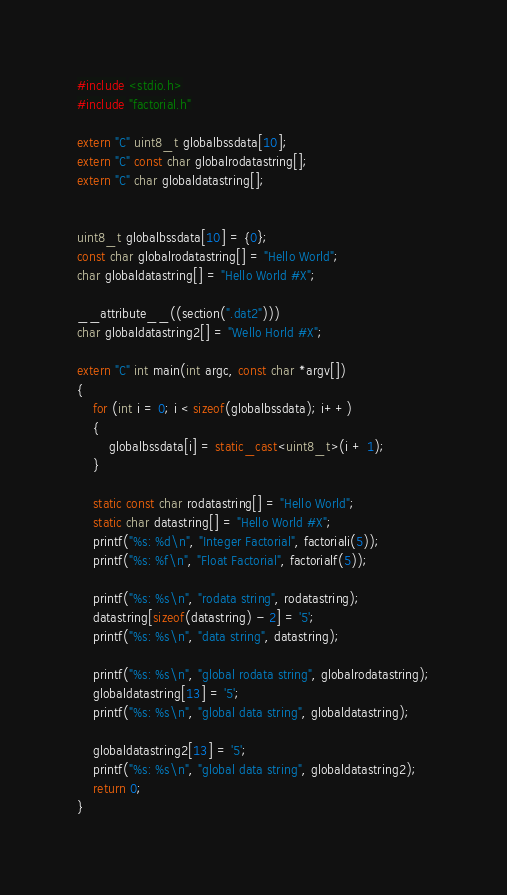<code> <loc_0><loc_0><loc_500><loc_500><_C++_>
#include <stdio.h>
#include "factorial.h"

extern "C" uint8_t globalbssdata[10];
extern "C" const char globalrodatastring[];
extern "C" char globaldatastring[];


uint8_t globalbssdata[10] = {0};
const char globalrodatastring[] = "Hello World";
char globaldatastring[] = "Hello World #X";

__attribute__((section(".dat2")))
char globaldatastring2[] = "Wello Horld #X";

extern "C" int main(int argc, const char *argv[])
{
    for (int i = 0; i < sizeof(globalbssdata); i++)
    {
        globalbssdata[i] = static_cast<uint8_t>(i + 1);
    }

    static const char rodatastring[] = "Hello World";
    static char datastring[] = "Hello World #X";
    printf("%s: %d\n", "Integer Factorial", factoriali(5));
    printf("%s: %f\n", "Float Factorial", factorialf(5));

    printf("%s: %s\n", "rodata string", rodatastring);
    datastring[sizeof(datastring) - 2] = '5';
    printf("%s: %s\n", "data string", datastring);

    printf("%s: %s\n", "global rodata string", globalrodatastring);
    globaldatastring[13] = '5';
    printf("%s: %s\n", "global data string", globaldatastring);

    globaldatastring2[13] = '5';
    printf("%s: %s\n", "global data string", globaldatastring2);
    return 0;
}
</code> 